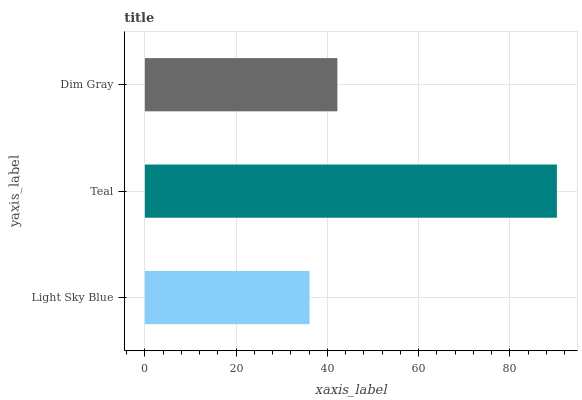Is Light Sky Blue the minimum?
Answer yes or no. Yes. Is Teal the maximum?
Answer yes or no. Yes. Is Dim Gray the minimum?
Answer yes or no. No. Is Dim Gray the maximum?
Answer yes or no. No. Is Teal greater than Dim Gray?
Answer yes or no. Yes. Is Dim Gray less than Teal?
Answer yes or no. Yes. Is Dim Gray greater than Teal?
Answer yes or no. No. Is Teal less than Dim Gray?
Answer yes or no. No. Is Dim Gray the high median?
Answer yes or no. Yes. Is Dim Gray the low median?
Answer yes or no. Yes. Is Light Sky Blue the high median?
Answer yes or no. No. Is Teal the low median?
Answer yes or no. No. 